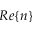<formula> <loc_0><loc_0><loc_500><loc_500>R e \{ n \}</formula> 